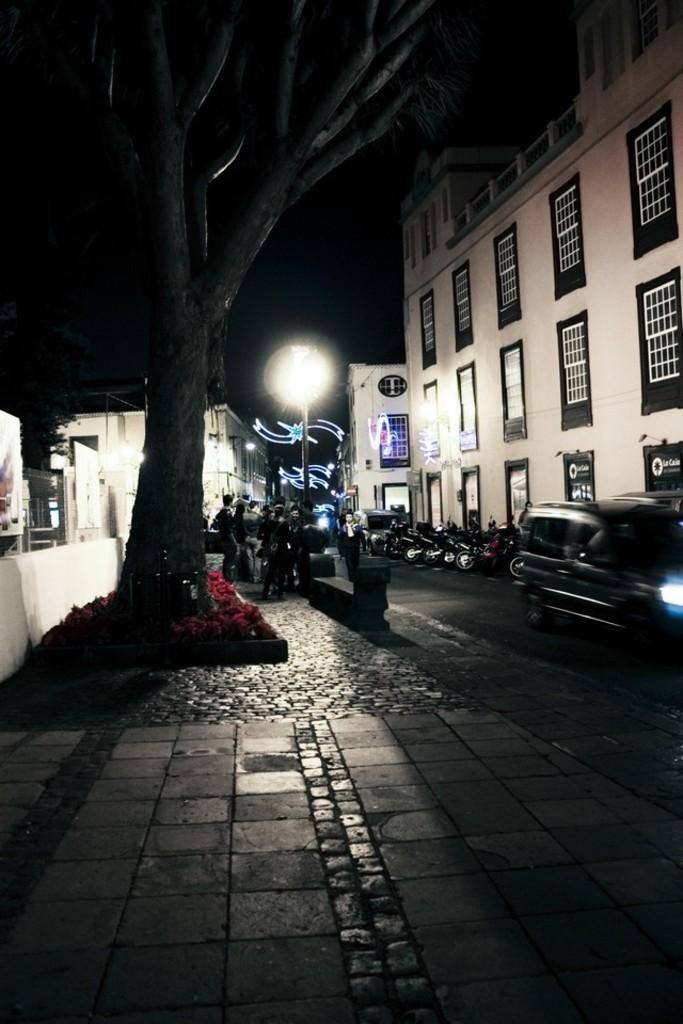In one or two sentences, can you explain what this image depicts? In this image I can see a building in white color, few vehicles on the road, light pole, trees and the background is in black color. 